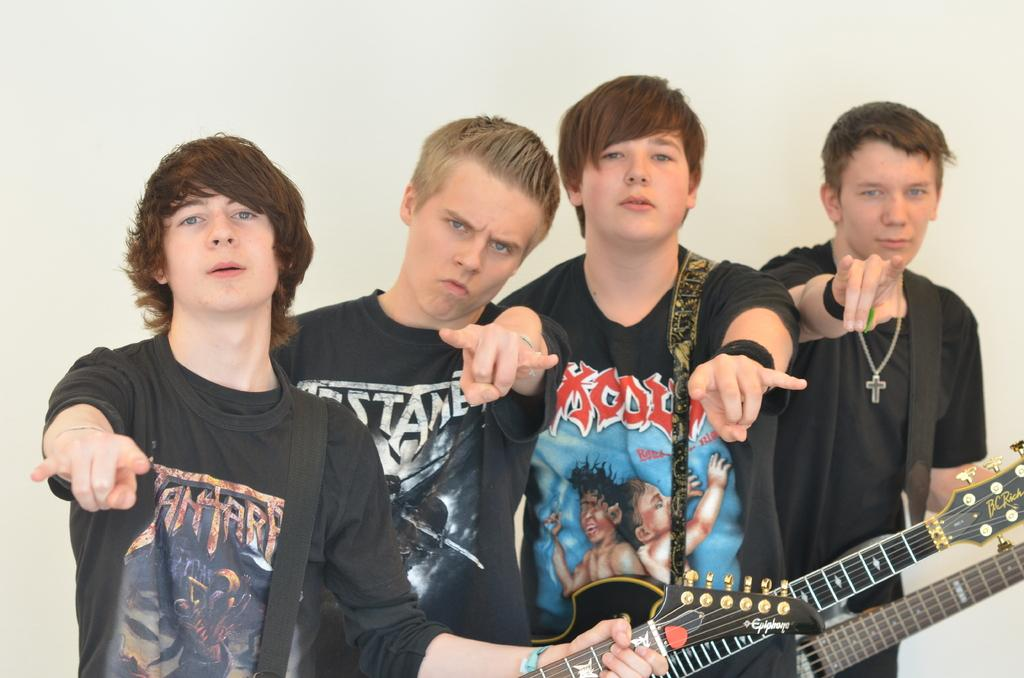How many people are in the image? There are four boys in the image. What are the boys wearing? The boys are wearing black t-shirts. What are the boys doing in the image? The boys are standing and playing guitars. What type of dolls can be seen playing with a quilt in the image? There are no dolls or quilts present in the image; it features four boys playing guitars. How much dirt is visible on the boys' shoes in the image? There is no information about the boys' shoes or the presence of dirt in the image. 